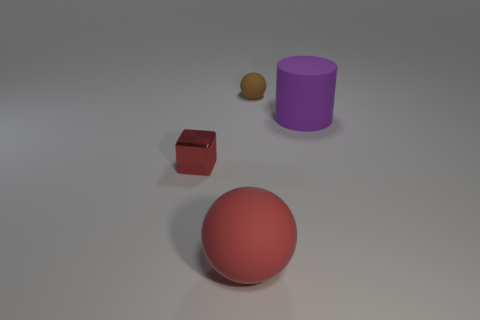Is there any other thing that is made of the same material as the red cube?
Offer a terse response. No. There is a cylinder; is its color the same as the thing that is in front of the tiny metallic cube?
Your response must be concise. No. There is a large object behind the big object in front of the purple rubber thing; how many big balls are behind it?
Ensure brevity in your answer.  0. There is a large red thing; are there any tiny metal things in front of it?
Offer a terse response. No. Is there any other thing of the same color as the tiny metallic block?
Give a very brief answer. Yes. How many spheres are either brown objects or red matte things?
Keep it short and to the point. 2. What number of objects are to the left of the purple thing and on the right side of the small red block?
Keep it short and to the point. 2. Is the number of red objects on the left side of the big red object the same as the number of purple cylinders that are on the right side of the large purple cylinder?
Give a very brief answer. No. There is a object that is behind the large cylinder; does it have the same shape as the large red rubber thing?
Ensure brevity in your answer.  Yes. What shape is the large thing behind the tiny object in front of the large purple thing that is behind the metallic thing?
Offer a very short reply. Cylinder. 